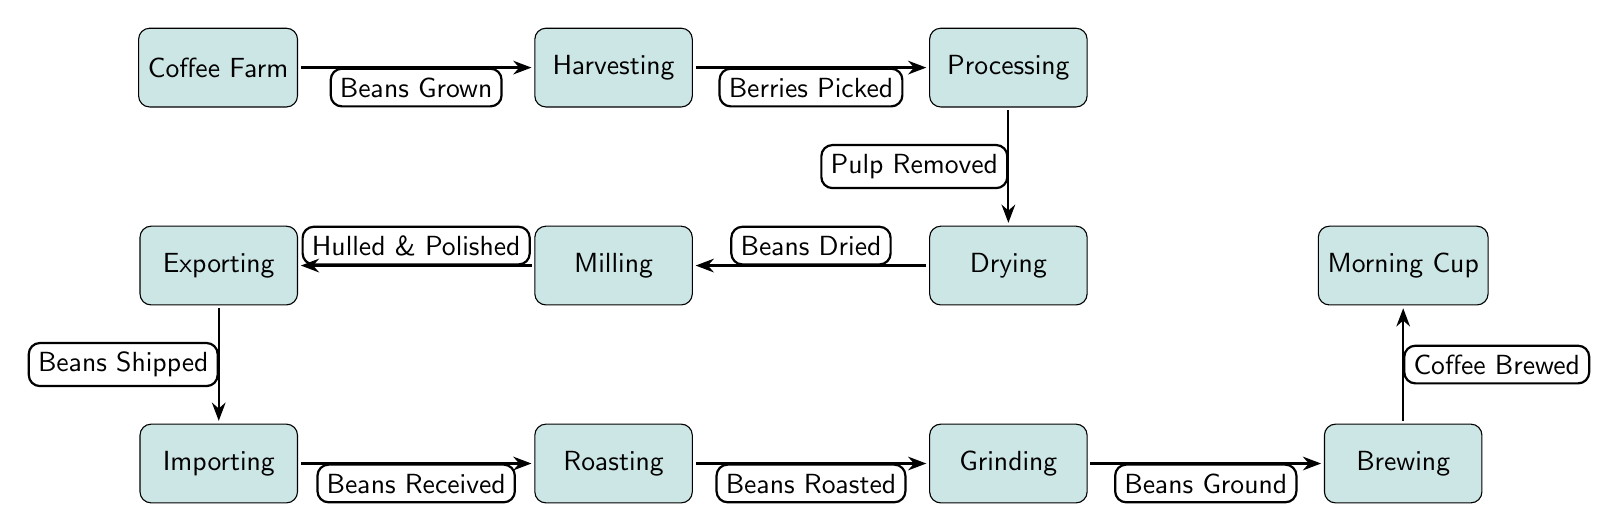What is the first step in the coffee bean journey? The diagram starts with the "Coffee Farm", indicating that this is where the journey begins with the cultivation of coffee beans.
Answer: Coffee Farm How many processes are involved in the coffee bean journey? By counting the nodes in the diagram, there are a total of 10 distinct processes from the starting point to the final cup.
Answer: 10 What happens after harvesting? According to the flow in the diagram, after "Harvesting", the next process is "Processing", indicating that the harvested berries are then processed for further steps.
Answer: Processing What is the last process before the morning cup? The last process before reaching the "Morning Cup" is "Brewing", which shows that the ground coffee is prepared for consumption just before becoming the final drink.
Answer: Brewing What describes the flow from drying to milling? The arrow shows that "Beans Dried" is the transition from the "Drying" process to the "Milling" process, indicating the progression in the journey of the beans.
Answer: Beans Dried What type of process is "Milling"? In the diagram, "Milling" is categorized as a process, represented in a rectangular shape, indicating it is an operational step in the journey of a coffee bean.
Answer: process What is removed during the processing stage? The diagram indicates that during "Processing", the "Pulp" is removed from the berries as part of the preparation for subsequent steps.
Answer: Pulp Removed How does the journey start? The journey begins with the cultivation and growth of coffee beans at the initial node, labeled as "Coffee Farm", which sets the stage for the entire process.
Answer: Beans Grown What is the relationship between importing and roasting? The arrow connecting these two nodes shows that after "Beans Received" during "Importing", the next step is "Roasting", indicating a direct relationship in the sequence of processes.
Answer: Beans Received 